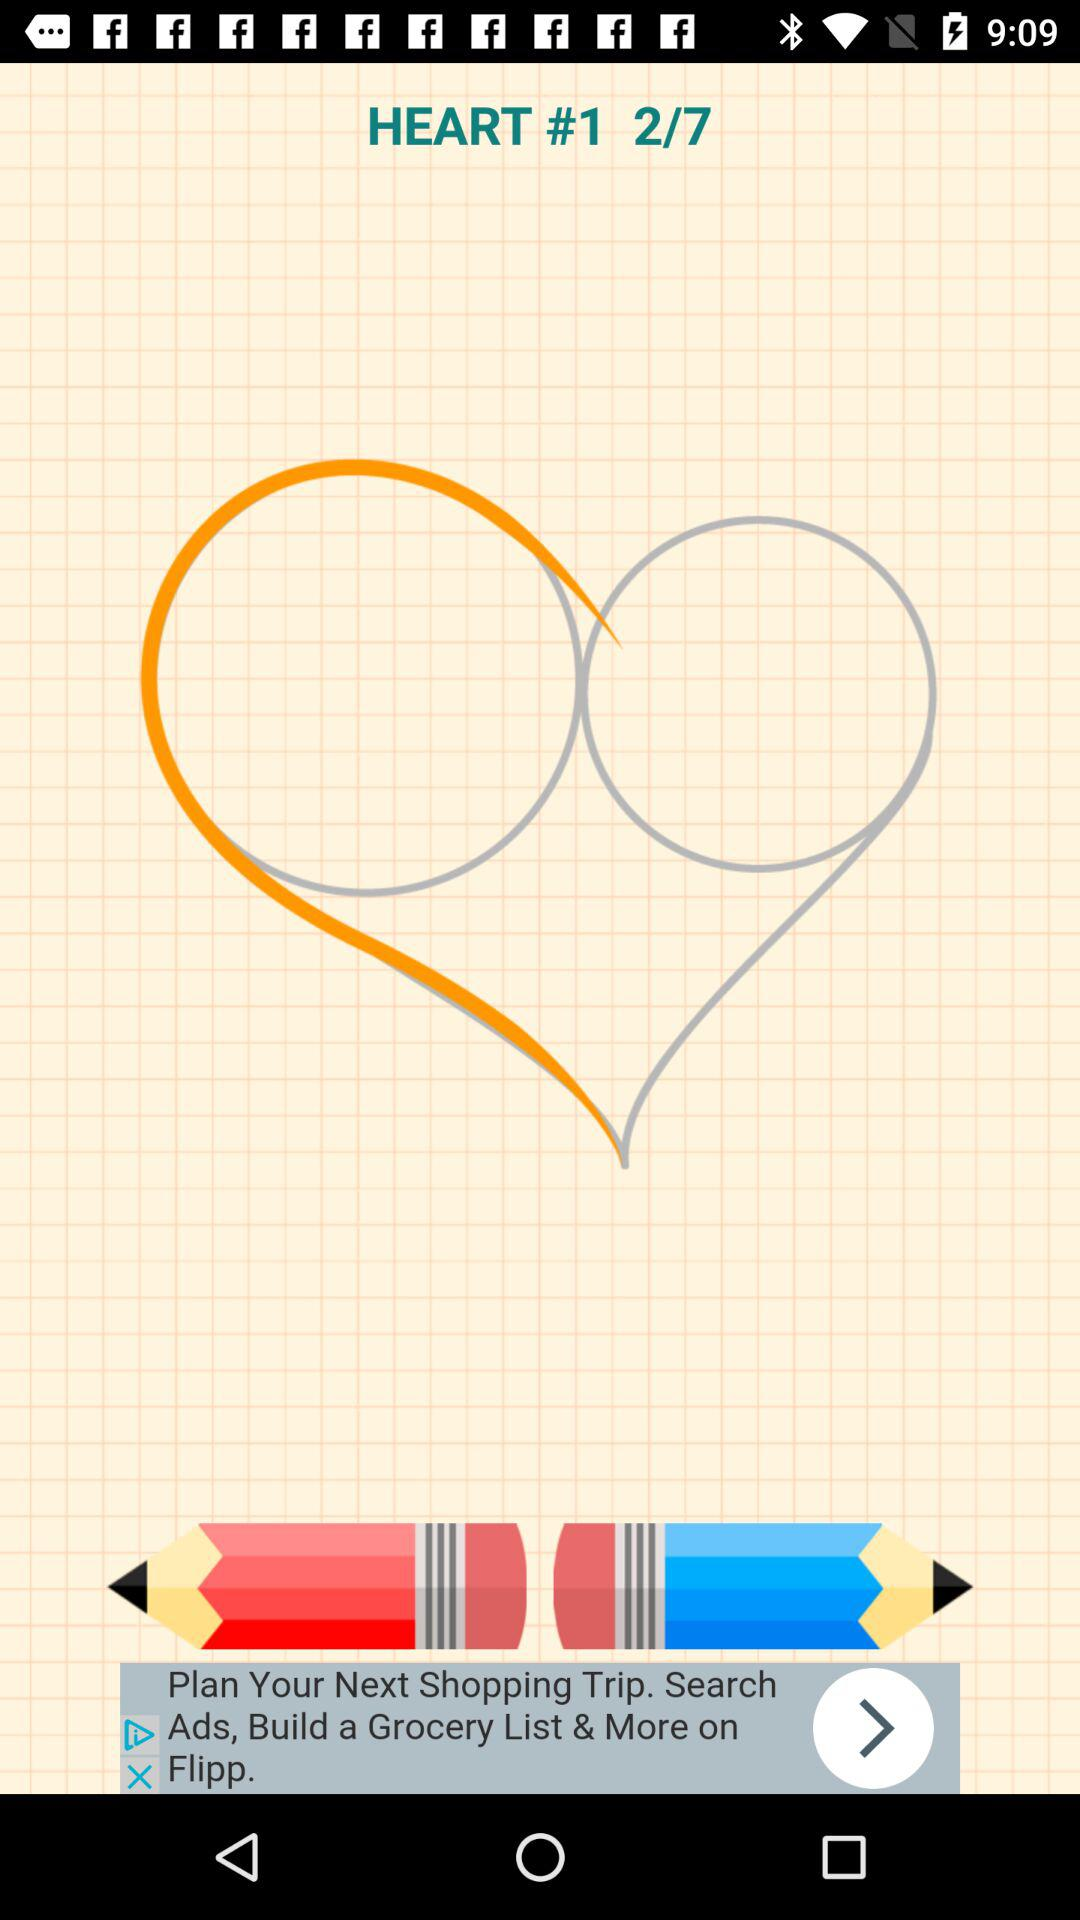What is the current page number? The current page number is 2. 